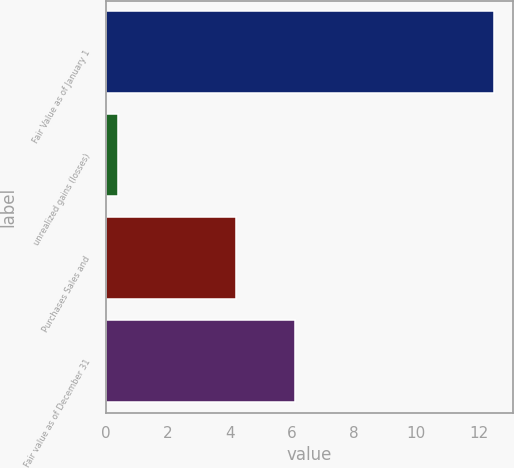Convert chart. <chart><loc_0><loc_0><loc_500><loc_500><bar_chart><fcel>Fair Value as of January 1<fcel>unrealized gains (losses)<fcel>Purchases Sales and<fcel>Fair value as of December 31<nl><fcel>12.5<fcel>0.4<fcel>4.2<fcel>6.1<nl></chart> 